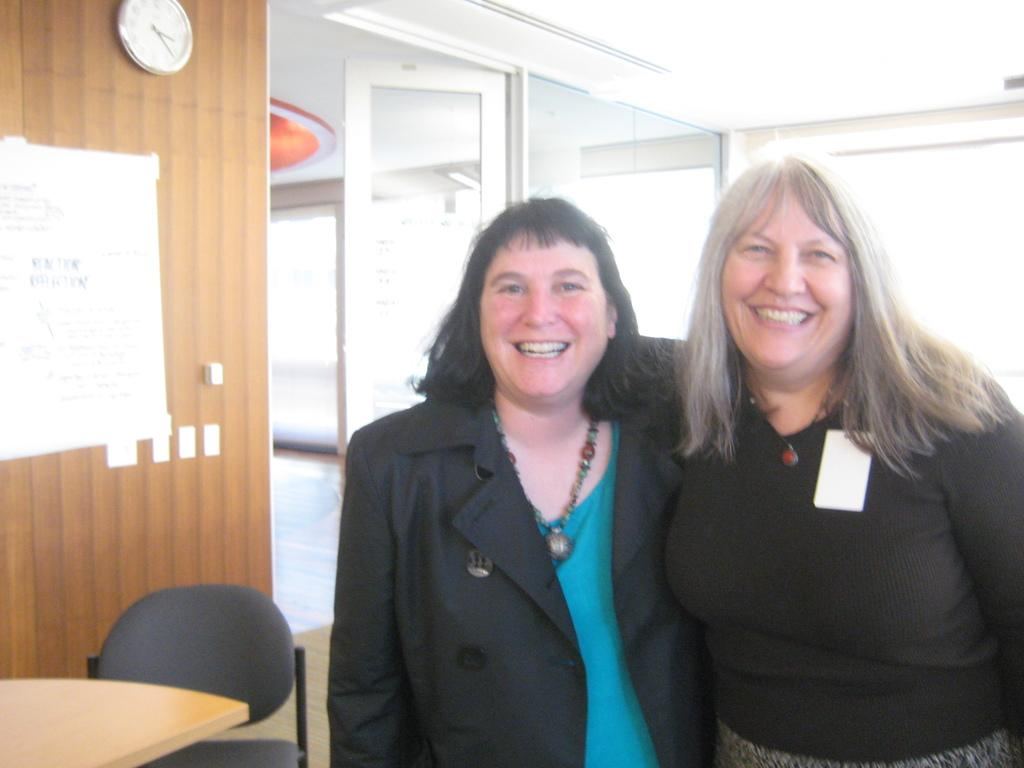How many people are in the image? There are two persons standing in the image. What can be seen in the background of the image? There is a wall, a clock, and a door in the background of the image. What furniture is present in the image? There is a chair and a table in the image. What part of the room is visible in the image? The floor is visible in the image. What type of string is being used to play with the family in the image? There is no string or family present in the image; it features two persons standing in a room with a wall, clock, door, chair, table, and visible floor. 